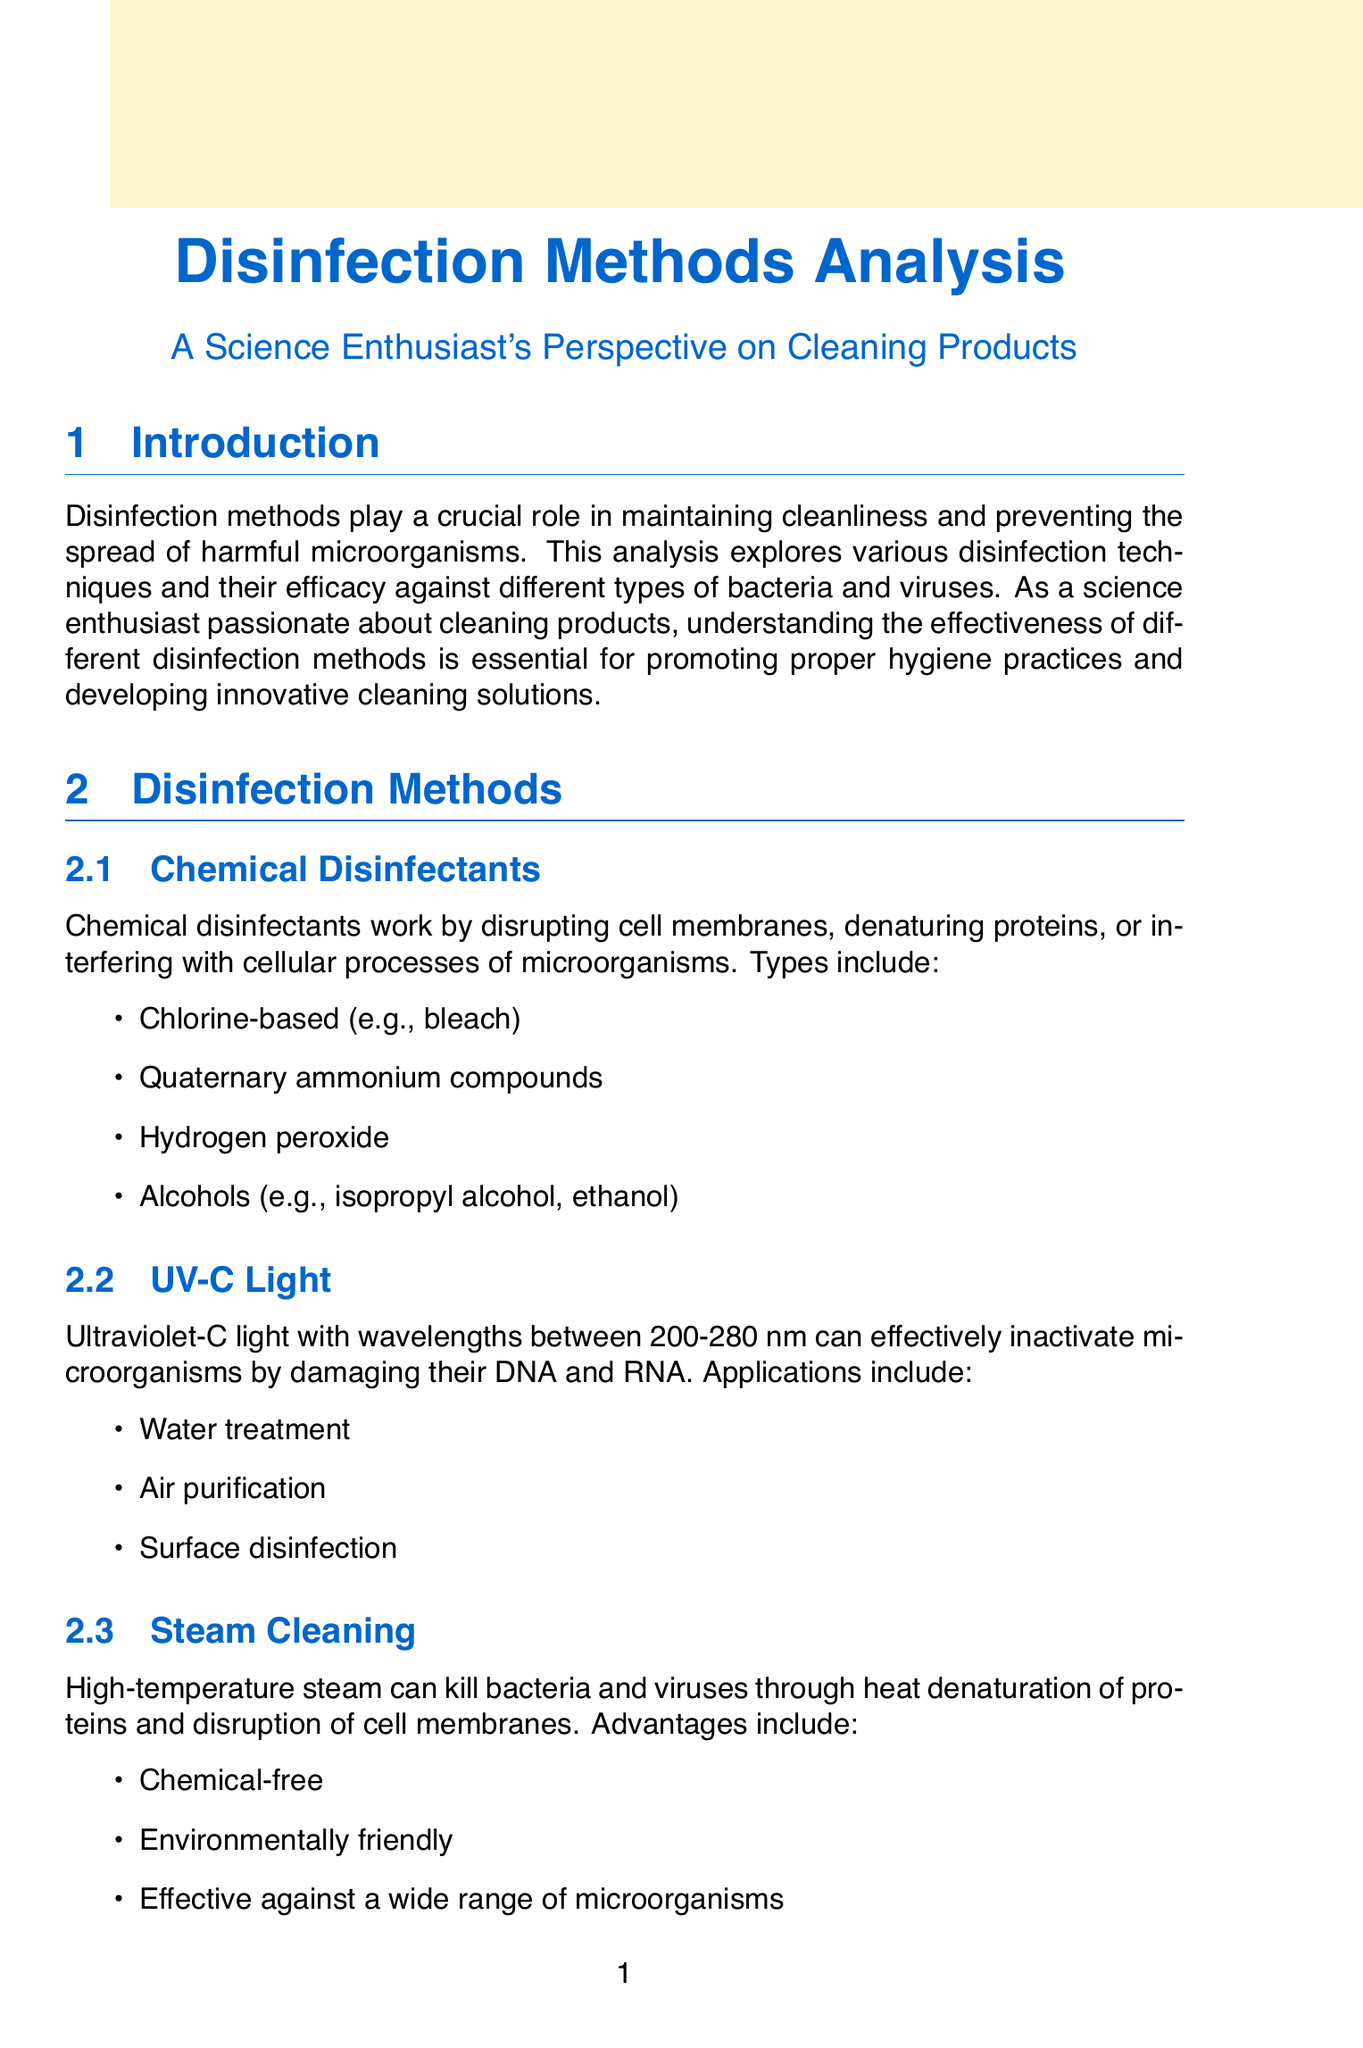What is the purpose of disinfection methods? Disinfection methods are crucial for maintaining cleanliness and preventing the spread of harmful microorganisms.
Answer: Preventing the spread of harmful microorganisms What are the types of chemical disinfectants mentioned? The document lists various types of chemical disinfectants including chlorine-based, quaternary ammonium compounds, hydrogen peroxide, and alcohols.
Answer: Chlorine-based, quaternary ammonium compounds, hydrogen peroxide, alcohols Which disinfection method is described as chemical-free and environmentally friendly? The method described as chemical-free and environmentally friendly is steam cleaning, which uses high-temperature steam to kill microorganisms.
Answer: Steam cleaning How many effective methods are listed for Escherichia coli? The document mentions three effective methods for Escherichia coli: chlorine-based disinfectants, UV-C light, and steam cleaning.
Answer: Three What factors affect the efficacy of disinfection methods? The document lists several factors, including contact time, concentration of disinfectant, presence of organic matter, temperature, and pH level.
Answer: Contact time, concentration of disinfectant, presence of organic matter, temperature, pH level What is the environmental impact of UV-C light? The document states that UV-C light is energy-efficient and environmentally friendly, indicating its minimal negative environmental impact.
Answer: Energy-efficient and environmentally friendly How is ozone treatment described in the document? The document describes ozone treatment as a powerful oxidizing agent that can destroy microorganisms by damaging their cell walls and genetic material.
Answer: A powerful oxidizing agent What is the focus of future research mentioned in the conclusion? The conclusion suggests that future research should explore novel disinfection technologies and optimize existing methods for improved efficacy and sustainability.
Answer: Novel disinfection technologies Which virus is mentioned alongside quaternary ammonium compounds in effective methods? The document mentions SARS-CoV-2 as being effectively treated with quaternary ammonium compounds, UV-C light, and alcohols.
Answer: SARS-CoV-2 